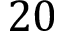<formula> <loc_0><loc_0><loc_500><loc_500>2 0</formula> 